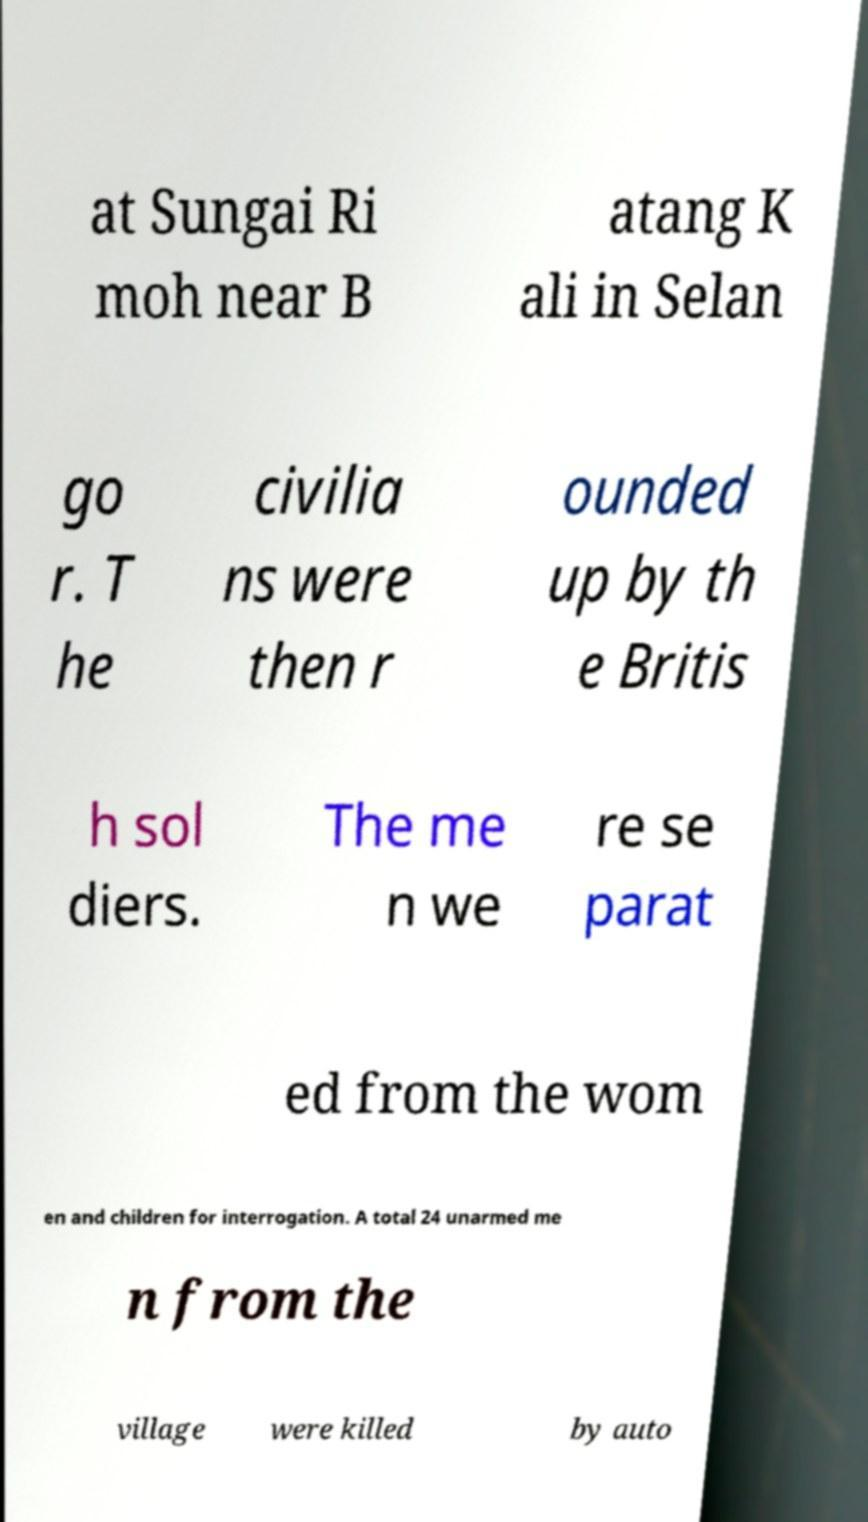There's text embedded in this image that I need extracted. Can you transcribe it verbatim? at Sungai Ri moh near B atang K ali in Selan go r. T he civilia ns were then r ounded up by th e Britis h sol diers. The me n we re se parat ed from the wom en and children for interrogation. A total 24 unarmed me n from the village were killed by auto 